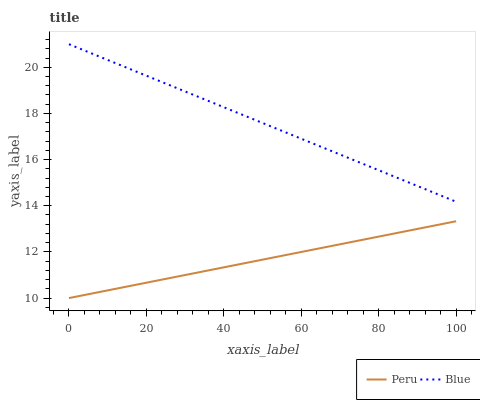Does Peru have the minimum area under the curve?
Answer yes or no. Yes. Does Blue have the maximum area under the curve?
Answer yes or no. Yes. Does Peru have the maximum area under the curve?
Answer yes or no. No. Is Peru the smoothest?
Answer yes or no. Yes. Is Blue the roughest?
Answer yes or no. Yes. Is Peru the roughest?
Answer yes or no. No. Does Peru have the highest value?
Answer yes or no. No. Is Peru less than Blue?
Answer yes or no. Yes. Is Blue greater than Peru?
Answer yes or no. Yes. Does Peru intersect Blue?
Answer yes or no. No. 